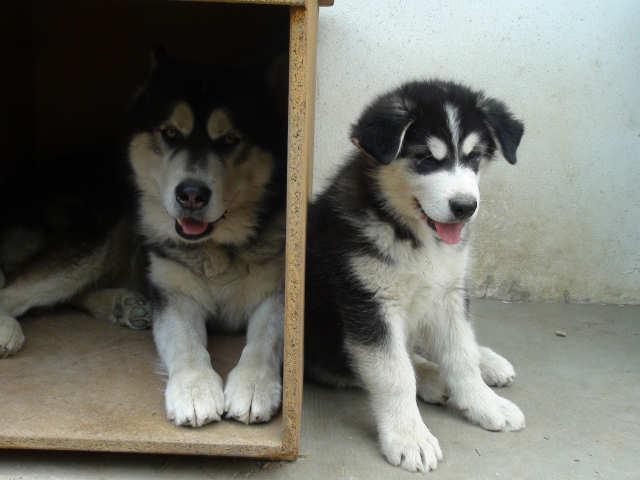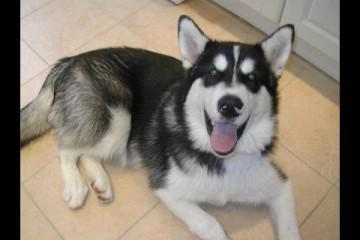The first image is the image on the left, the second image is the image on the right. Considering the images on both sides, is "The left and right image contains the same number of dogs." valid? Answer yes or no. No. The first image is the image on the left, the second image is the image on the right. Considering the images on both sides, is "There are exactly three dogs in total." valid? Answer yes or no. Yes. 